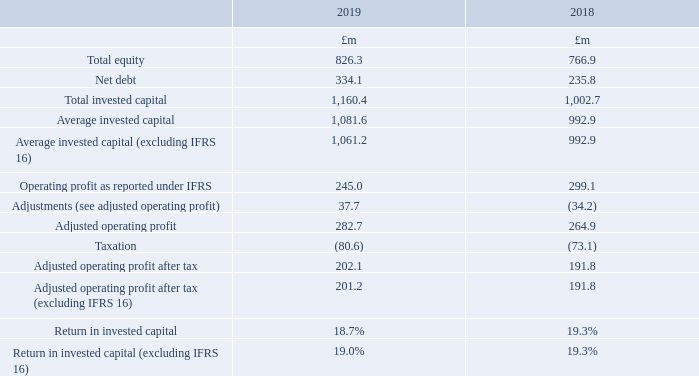Return on invested capital (ROIC)
ROIC measures the after tax return on the total capital invested in the business. It is calculated as adjusted operating profit after tax divided by average invested capital.
An analysis of the components is as follows:
What does the ROIC measure? The after tax return on the total capital invested in the business. How is the ROIC calculated? Adjusted operating profit after tax divided by average invested capital. What are the components factored in when calculating the total invested capital? Total equity, net debt. In which year was the amount of adjusted operating profit after tax (excluding IFRS 16) larger? 201.2>191.8
Answer: 2019. What is the change in net debt in 2019 from 2018?
Answer scale should be: million. 334.1-235.8
Answer: 98.3. What is the percentage change in net debt in 2019 from 2018?
Answer scale should be: percent. (334.1-235.8)/235.8
Answer: 41.69. 